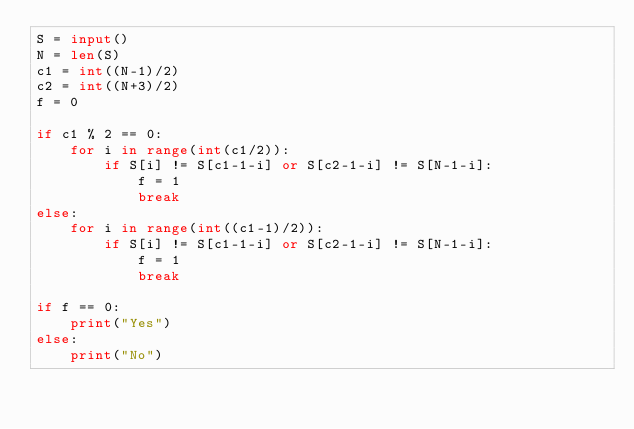Convert code to text. <code><loc_0><loc_0><loc_500><loc_500><_Python_>S = input()
N = len(S)
c1 = int((N-1)/2)
c2 = int((N+3)/2)
f = 0

if c1 % 2 == 0:
    for i in range(int(c1/2)):
        if S[i] != S[c1-1-i] or S[c2-1-i] != S[N-1-i]:
            f = 1
            break
else:
    for i in range(int((c1-1)/2)):
        if S[i] != S[c1-1-i] or S[c2-1-i] != S[N-1-i]:
            f = 1
            break

if f == 0:
    print("Yes")
else:
    print("No")</code> 